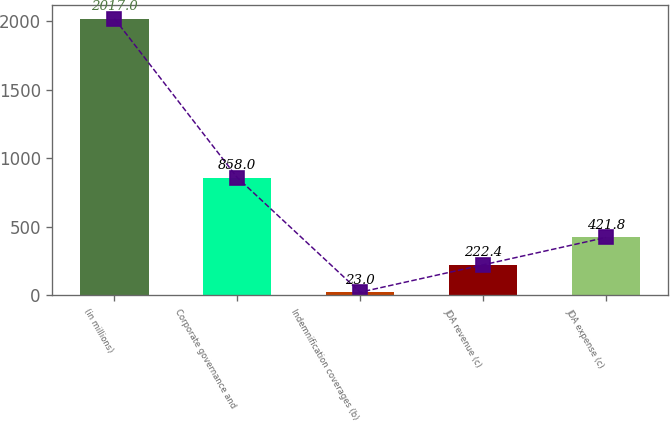Convert chart to OTSL. <chart><loc_0><loc_0><loc_500><loc_500><bar_chart><fcel>(in millions)<fcel>Corporate governance and<fcel>Indemnification coverages (b)<fcel>JDA revenue (c)<fcel>JDA expense (c)<nl><fcel>2017<fcel>858<fcel>23<fcel>222.4<fcel>421.8<nl></chart> 